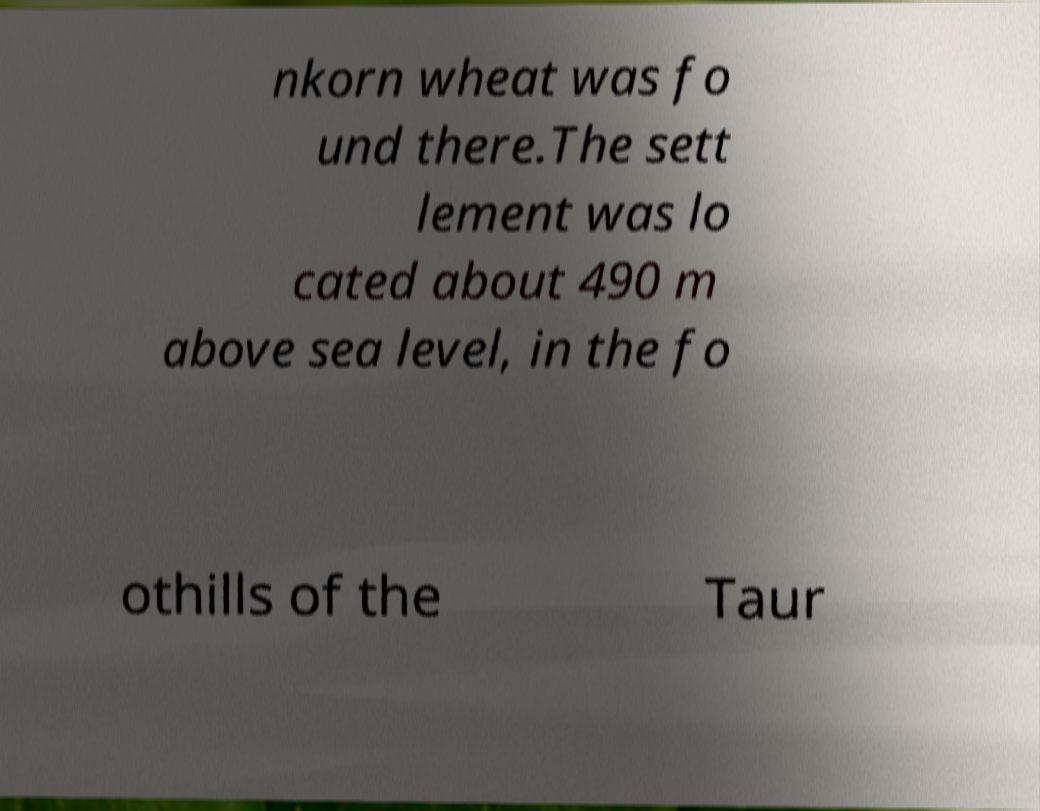Can you accurately transcribe the text from the provided image for me? nkorn wheat was fo und there.The sett lement was lo cated about 490 m above sea level, in the fo othills of the Taur 